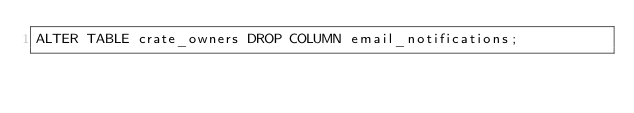<code> <loc_0><loc_0><loc_500><loc_500><_SQL_>ALTER TABLE crate_owners DROP COLUMN email_notifications;
</code> 